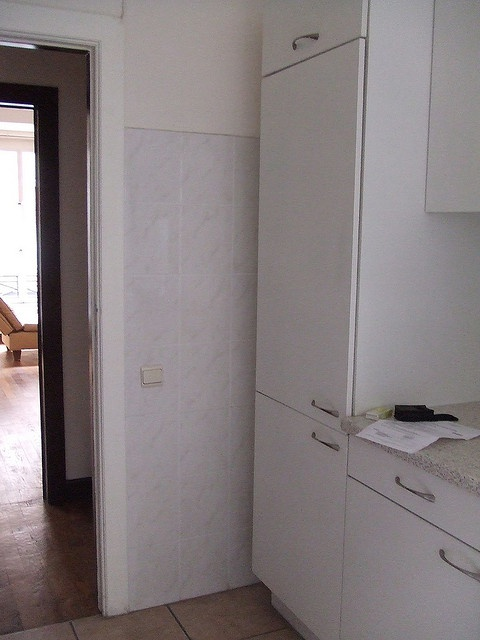Describe the objects in this image and their specific colors. I can see a chair in gray, brown, and maroon tones in this image. 